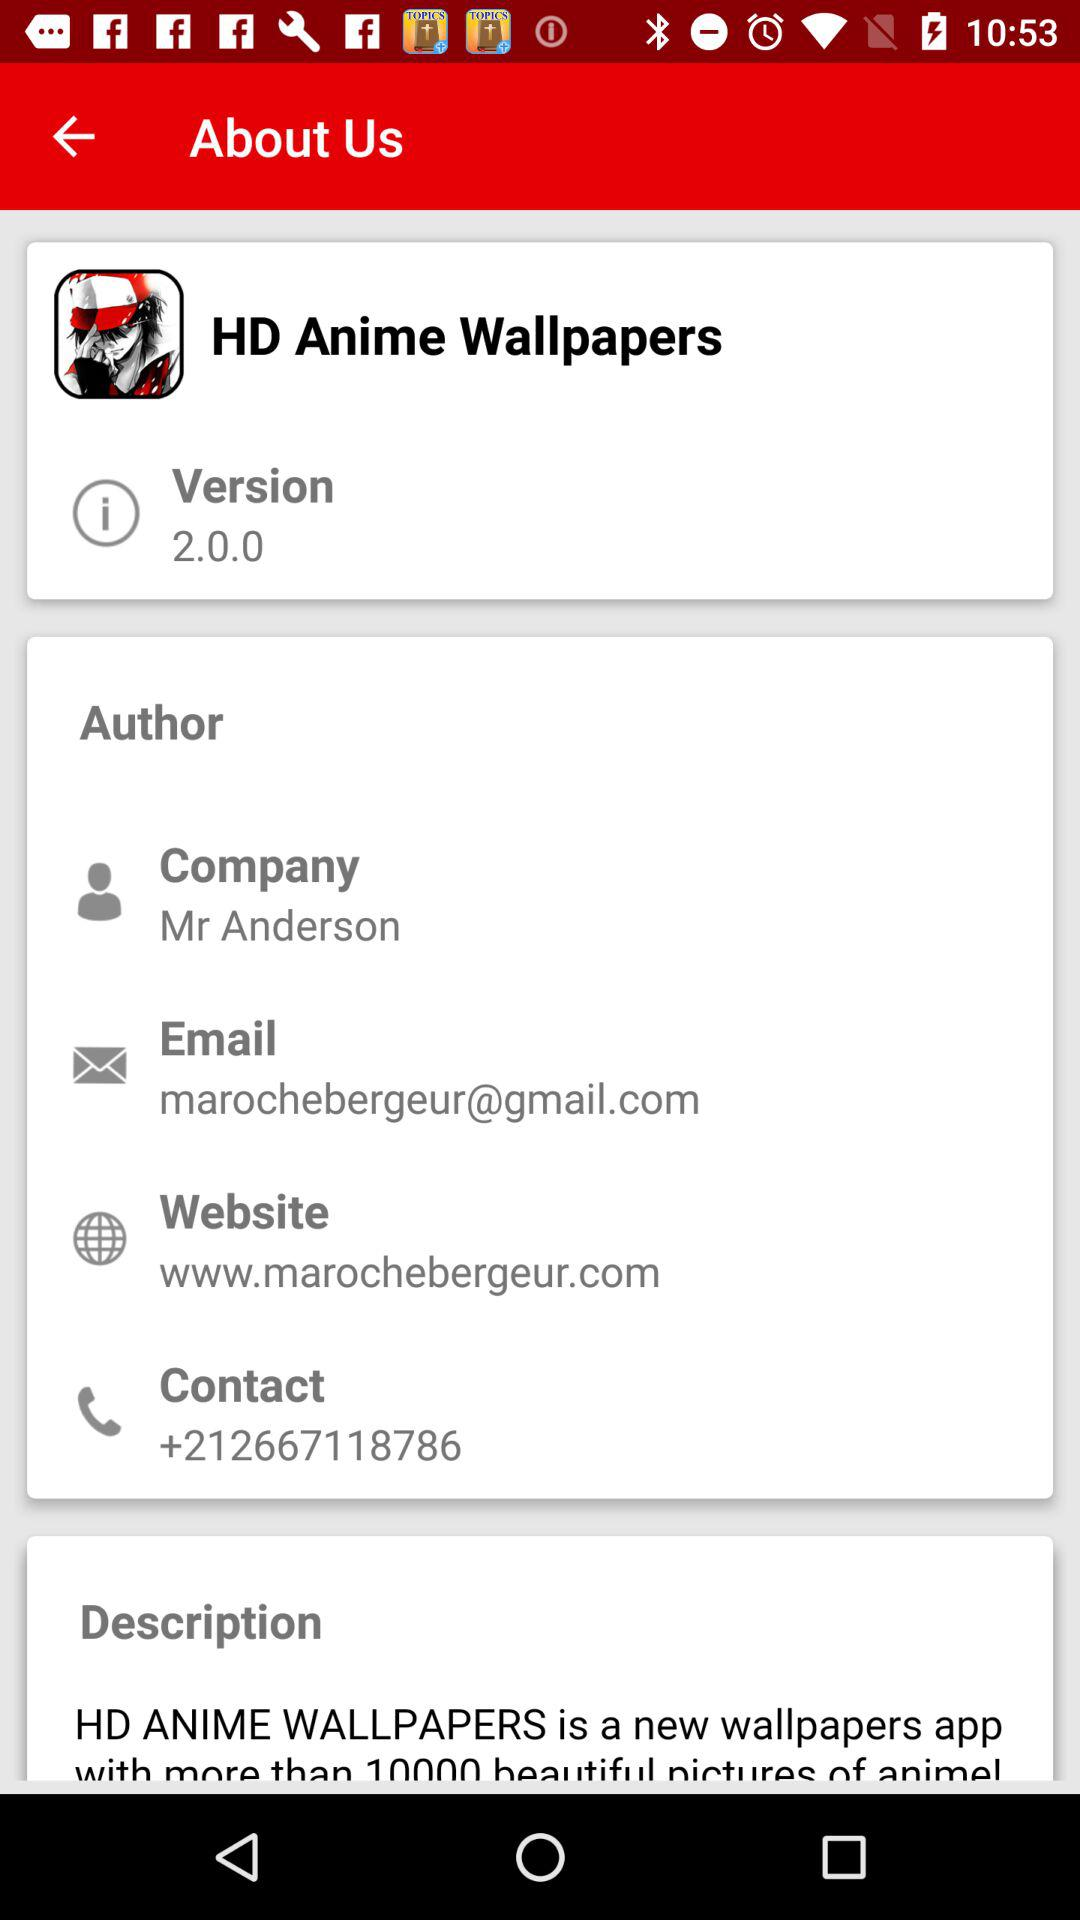What is the email address of the user? The email address of the user is marochebergeur@gmail.com. 